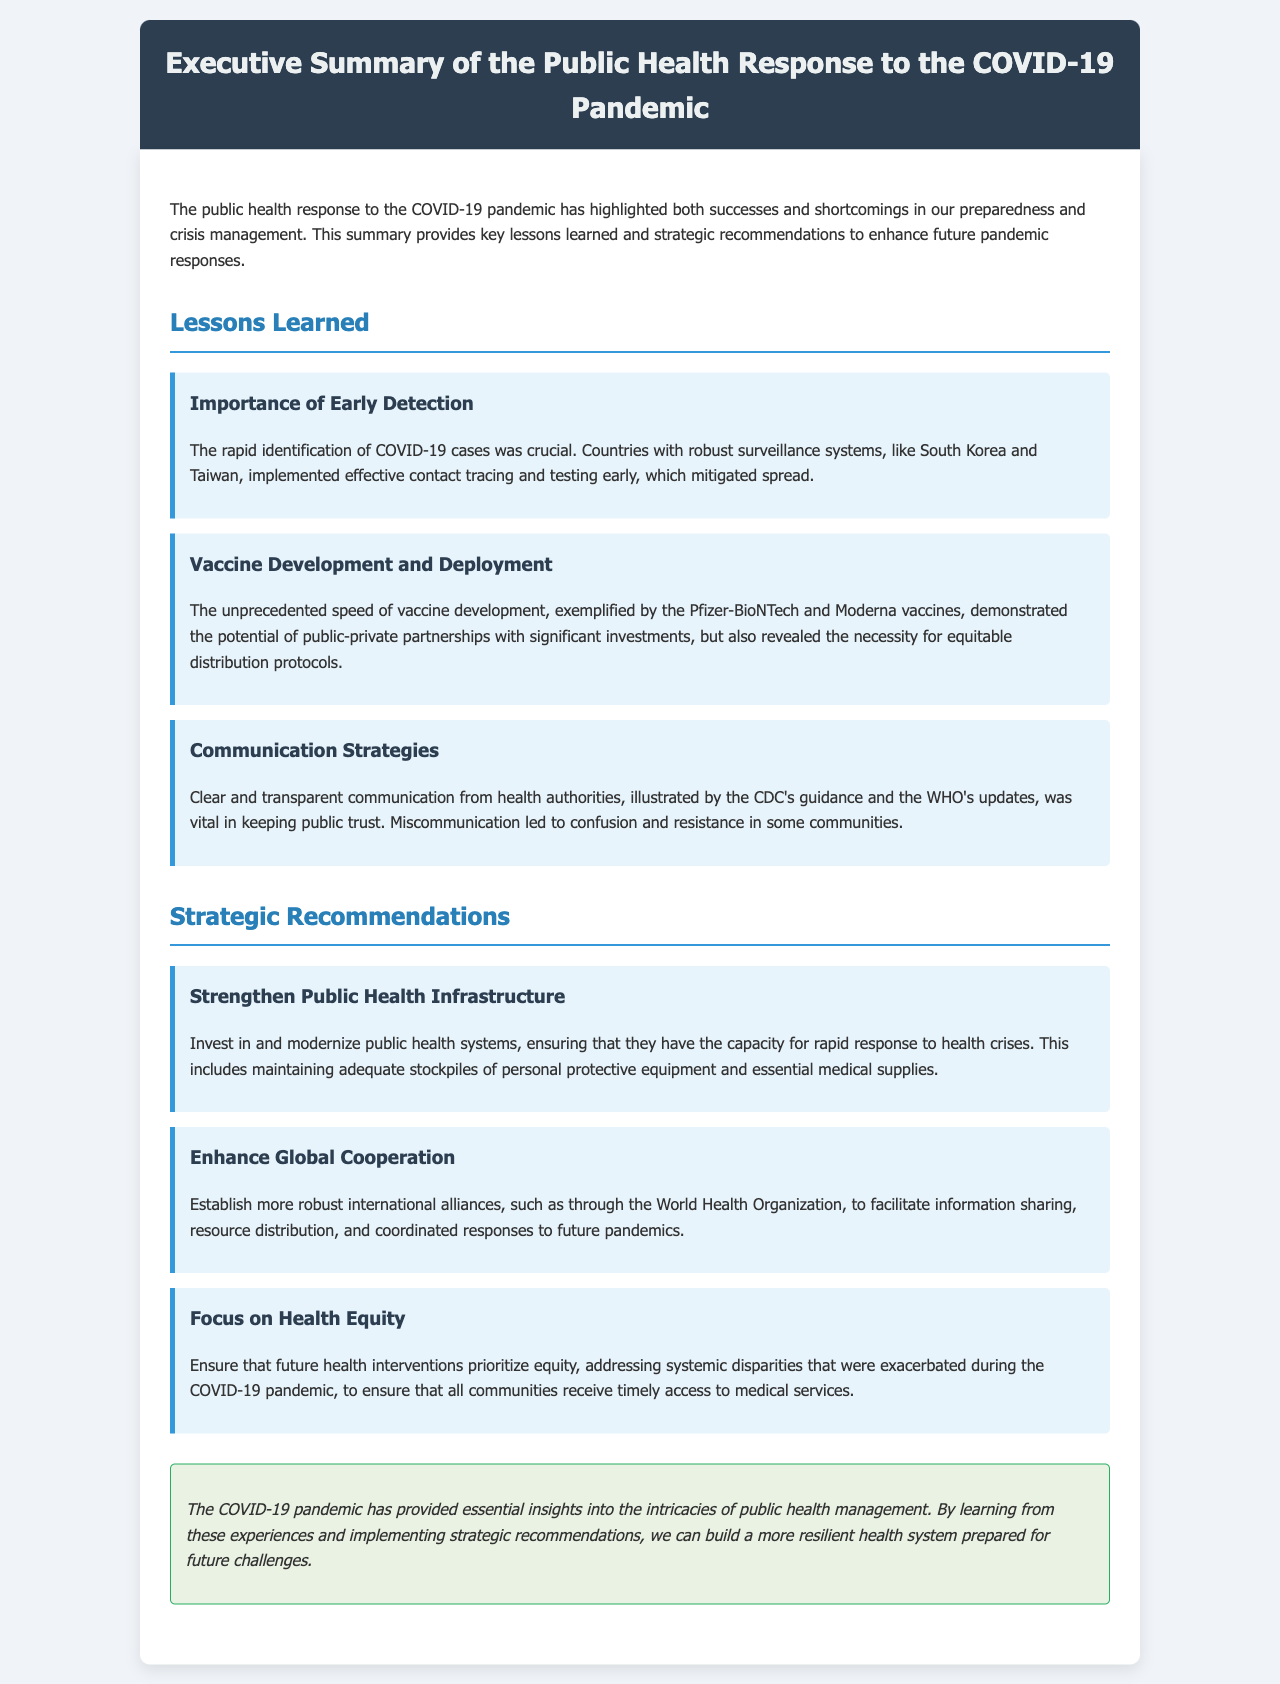What is the title of the document? The title of the document is provided in the header section.
Answer: Executive Summary of the Public Health Response to the COVID-19 Pandemic What are the three main lessons learned? The lessons learned are explicitly listed in the section titled "Lessons Learned."
Answer: Importance of Early Detection, Vaccine Development and Deployment, Communication Strategies Which countries are mentioned for their robust surveillance systems? The countries are specifically noted in the lesson about early detection as examples of effective response.
Answer: South Korea and Taiwan What recommendation relates to international collaboration? The recommendations section includes identifying strategies for global partnerships.
Answer: Enhance Global Cooperation What was vital for maintaining public trust during the pandemic? The document discusses the role of health authorities in conveying information, leading to public trust.
Answer: Clear and transparent communication What is highlighted as a necessary focus for future health interventions? The recommendations emphasize addressing inequalities as a priority in health interventions.
Answer: Health Equity How many strategic recommendations are provided? The count of recommendations is stated in the strategic recommendations section.
Answer: Three What does the conclusion note about the pandemic's insights? The conclusion summarizes the overall lessons regarding public health management learned from the pandemic.
Answer: Essential insights into the intricacies of public health management 